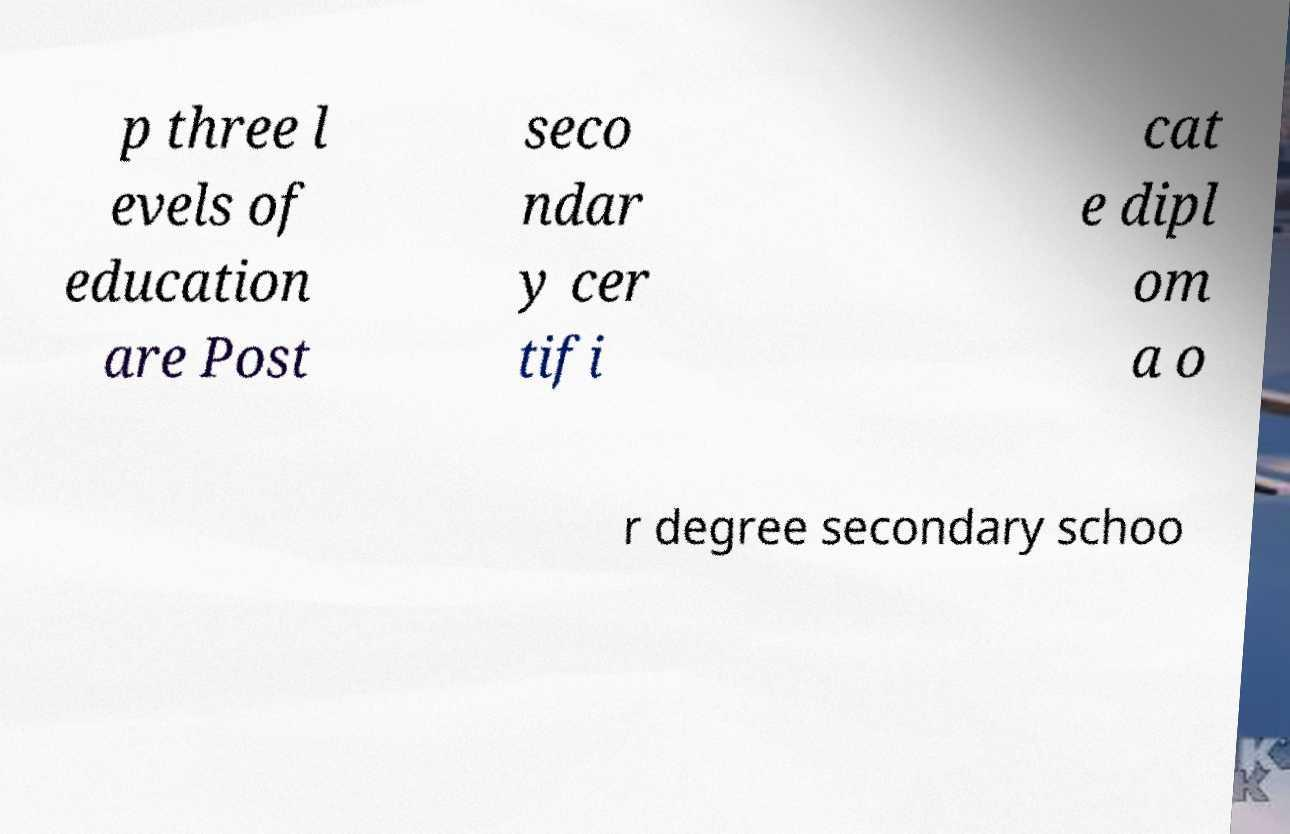Please identify and transcribe the text found in this image. p three l evels of education are Post seco ndar y cer tifi cat e dipl om a o r degree secondary schoo 